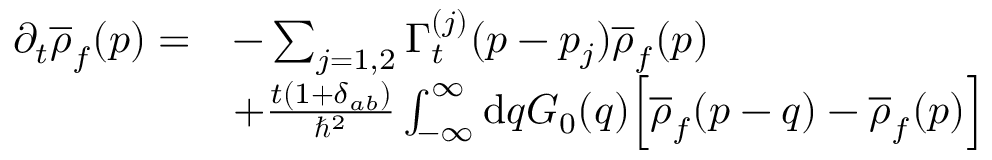Convert formula to latex. <formula><loc_0><loc_0><loc_500><loc_500>\begin{array} { r l } { \partial _ { t } \overline { \rho } _ { f } ( p ) = } & { - \sum _ { j = 1 , 2 } \Gamma _ { t } ^ { ( j ) } ( p - p _ { j } ) \overline { \rho } _ { f } ( p ) } \\ & { + \frac { t ( 1 + \delta _ { a b } ) } { \hbar { ^ } { 2 } } \int _ { - \infty } ^ { \infty } d q G _ { 0 } ( q ) \left [ \overline { \rho } _ { f } ( p - q ) - \overline { \rho } _ { f } ( p ) \right ] } \end{array}</formula> 